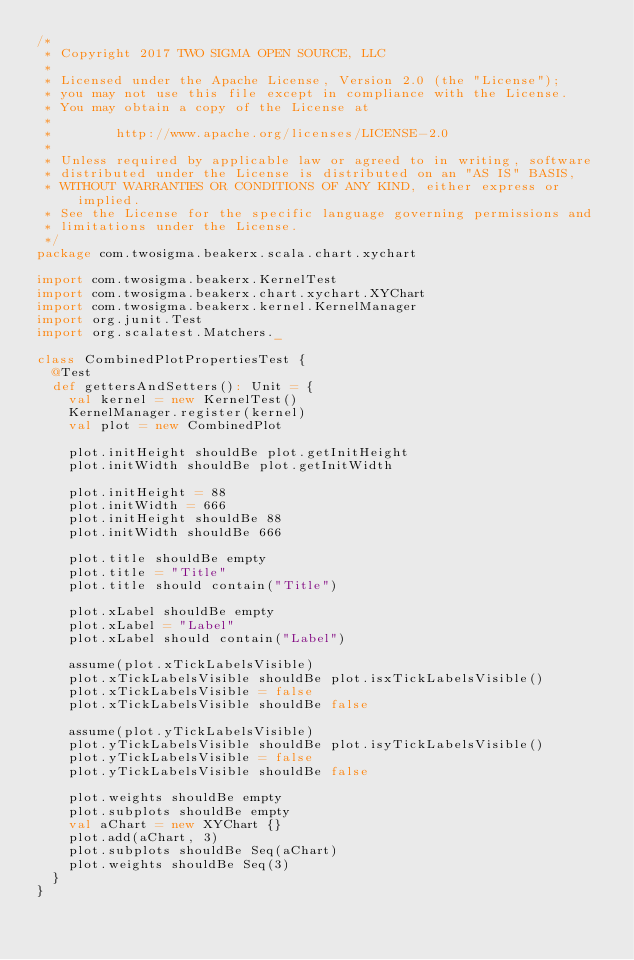Convert code to text. <code><loc_0><loc_0><loc_500><loc_500><_Scala_>/*
 * Copyright 2017 TWO SIGMA OPEN SOURCE, LLC
 *
 * Licensed under the Apache License, Version 2.0 (the "License");
 * you may not use this file except in compliance with the License.
 * You may obtain a copy of the License at
 *
 *        http://www.apache.org/licenses/LICENSE-2.0
 *
 * Unless required by applicable law or agreed to in writing, software
 * distributed under the License is distributed on an "AS IS" BASIS,
 * WITHOUT WARRANTIES OR CONDITIONS OF ANY KIND, either express or implied.
 * See the License for the specific language governing permissions and
 * limitations under the License.
 */
package com.twosigma.beakerx.scala.chart.xychart

import com.twosigma.beakerx.KernelTest
import com.twosigma.beakerx.chart.xychart.XYChart
import com.twosigma.beakerx.kernel.KernelManager
import org.junit.Test
import org.scalatest.Matchers._

class CombinedPlotPropertiesTest {
  @Test
  def gettersAndSetters(): Unit = {
    val kernel = new KernelTest()
    KernelManager.register(kernel)
    val plot = new CombinedPlot

    plot.initHeight shouldBe plot.getInitHeight
    plot.initWidth shouldBe plot.getInitWidth

    plot.initHeight = 88
    plot.initWidth = 666
    plot.initHeight shouldBe 88
    plot.initWidth shouldBe 666

    plot.title shouldBe empty
    plot.title = "Title"
    plot.title should contain("Title")

    plot.xLabel shouldBe empty
    plot.xLabel = "Label"
    plot.xLabel should contain("Label")

    assume(plot.xTickLabelsVisible)
    plot.xTickLabelsVisible shouldBe plot.isxTickLabelsVisible()
    plot.xTickLabelsVisible = false
    plot.xTickLabelsVisible shouldBe false

    assume(plot.yTickLabelsVisible)
    plot.yTickLabelsVisible shouldBe plot.isyTickLabelsVisible()
    plot.yTickLabelsVisible = false
    plot.yTickLabelsVisible shouldBe false

    plot.weights shouldBe empty
    plot.subplots shouldBe empty
    val aChart = new XYChart {}
    plot.add(aChart, 3)
    plot.subplots shouldBe Seq(aChart)
    plot.weights shouldBe Seq(3)
  }
}</code> 